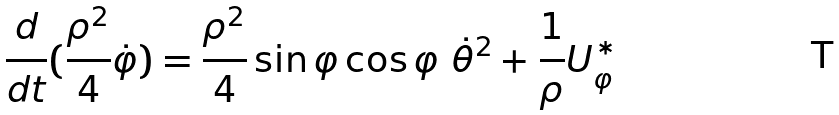<formula> <loc_0><loc_0><loc_500><loc_500>\frac { d } { d t } ( \frac { \rho ^ { 2 } } { 4 } \dot { \varphi } ) = \frac { \rho ^ { 2 } } { 4 } \sin \varphi \cos \varphi \text { } \dot { \theta } ^ { 2 } + \frac { 1 } { \rho } U _ { \varphi } ^ { \ast }</formula> 